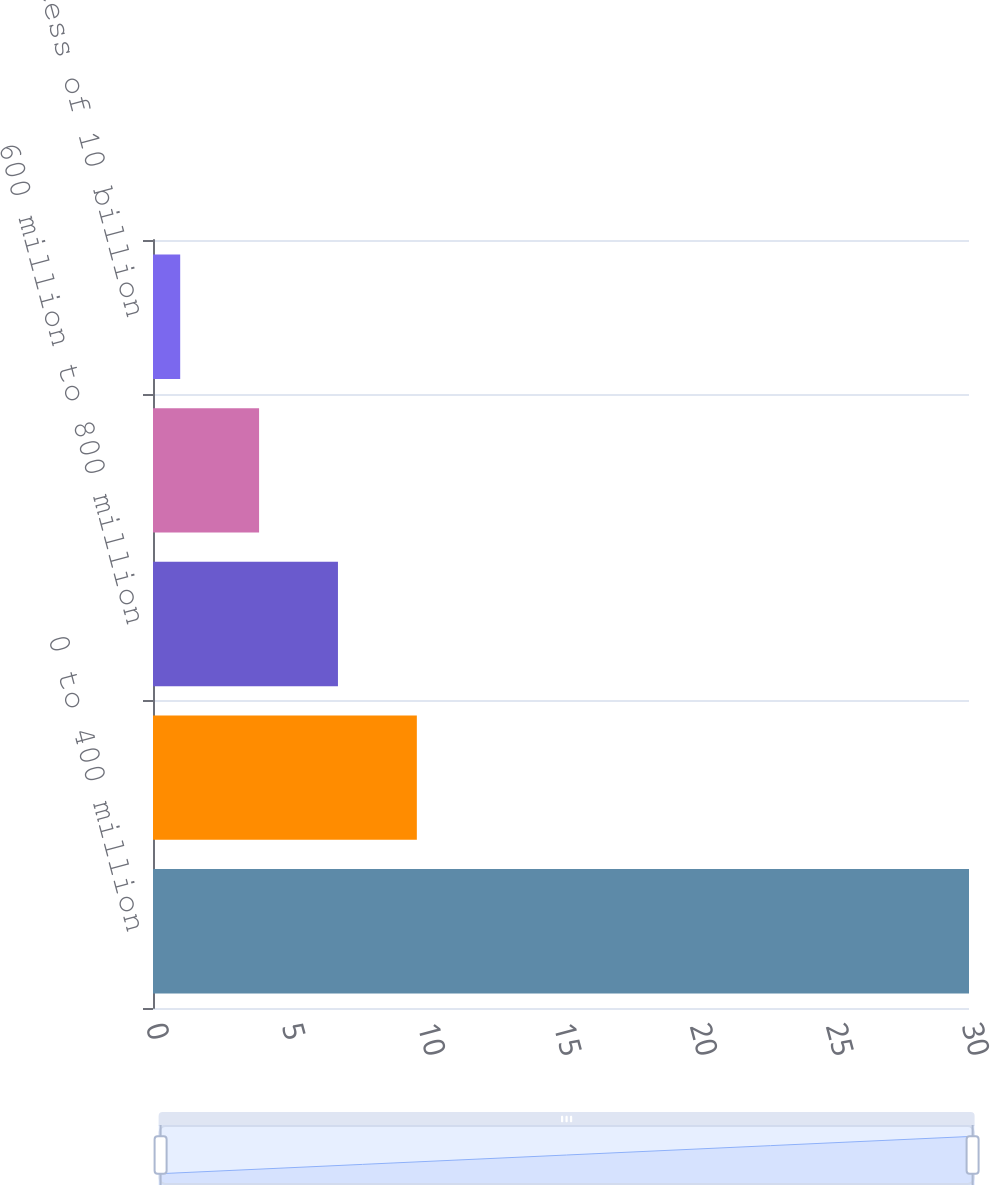Convert chart to OTSL. <chart><loc_0><loc_0><loc_500><loc_500><bar_chart><fcel>0 to 400 million<fcel>400 million to 600 million<fcel>600 million to 800 million<fcel>800 million to 10 billion<fcel>In excess of 10 billion<nl><fcel>30<fcel>9.7<fcel>6.8<fcel>3.9<fcel>1<nl></chart> 